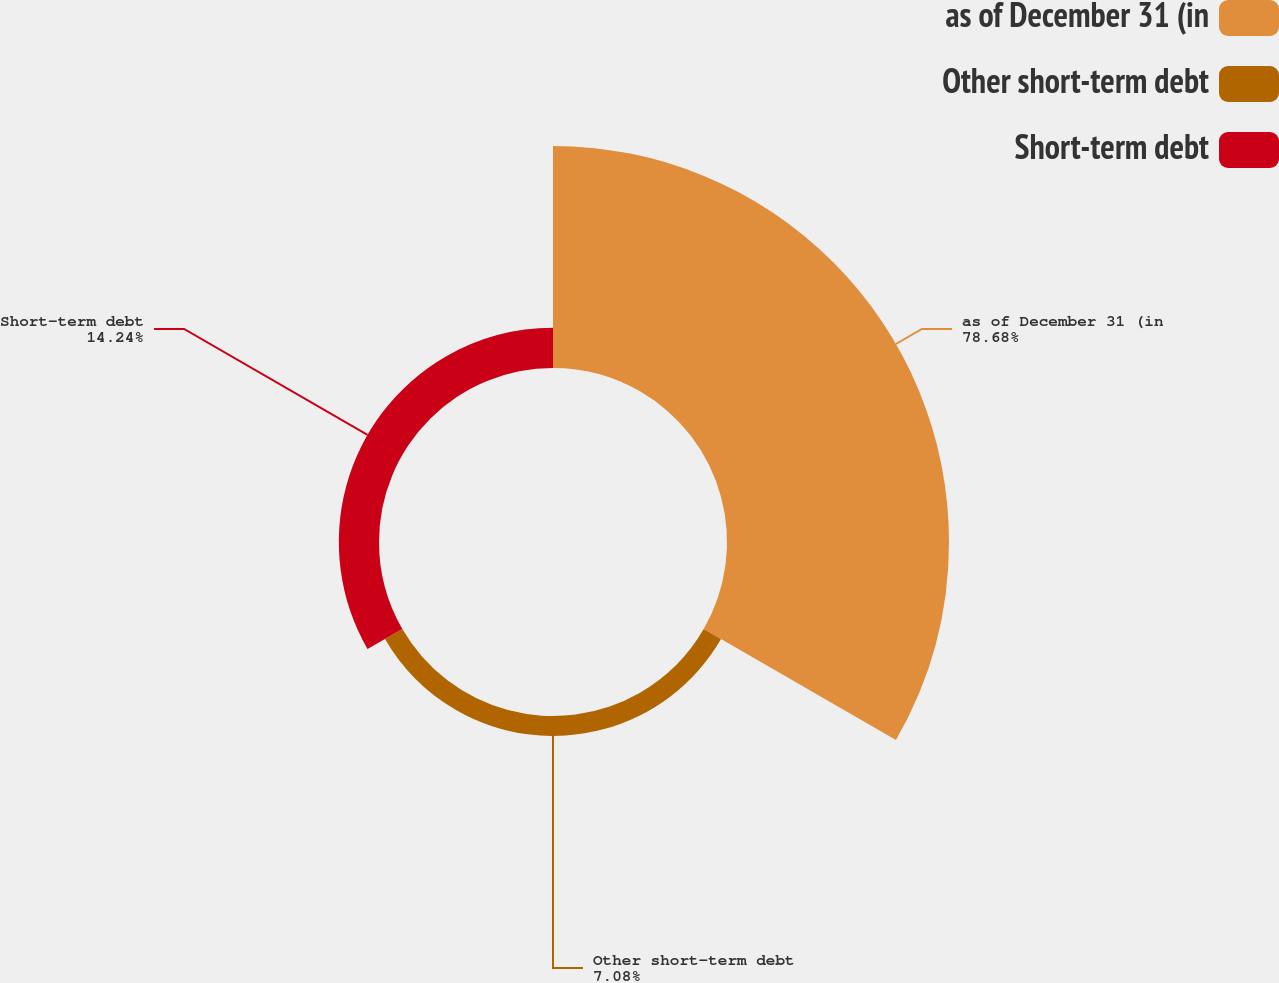Convert chart to OTSL. <chart><loc_0><loc_0><loc_500><loc_500><pie_chart><fcel>as of December 31 (in<fcel>Other short-term debt<fcel>Short-term debt<nl><fcel>78.69%<fcel>7.08%<fcel>14.24%<nl></chart> 